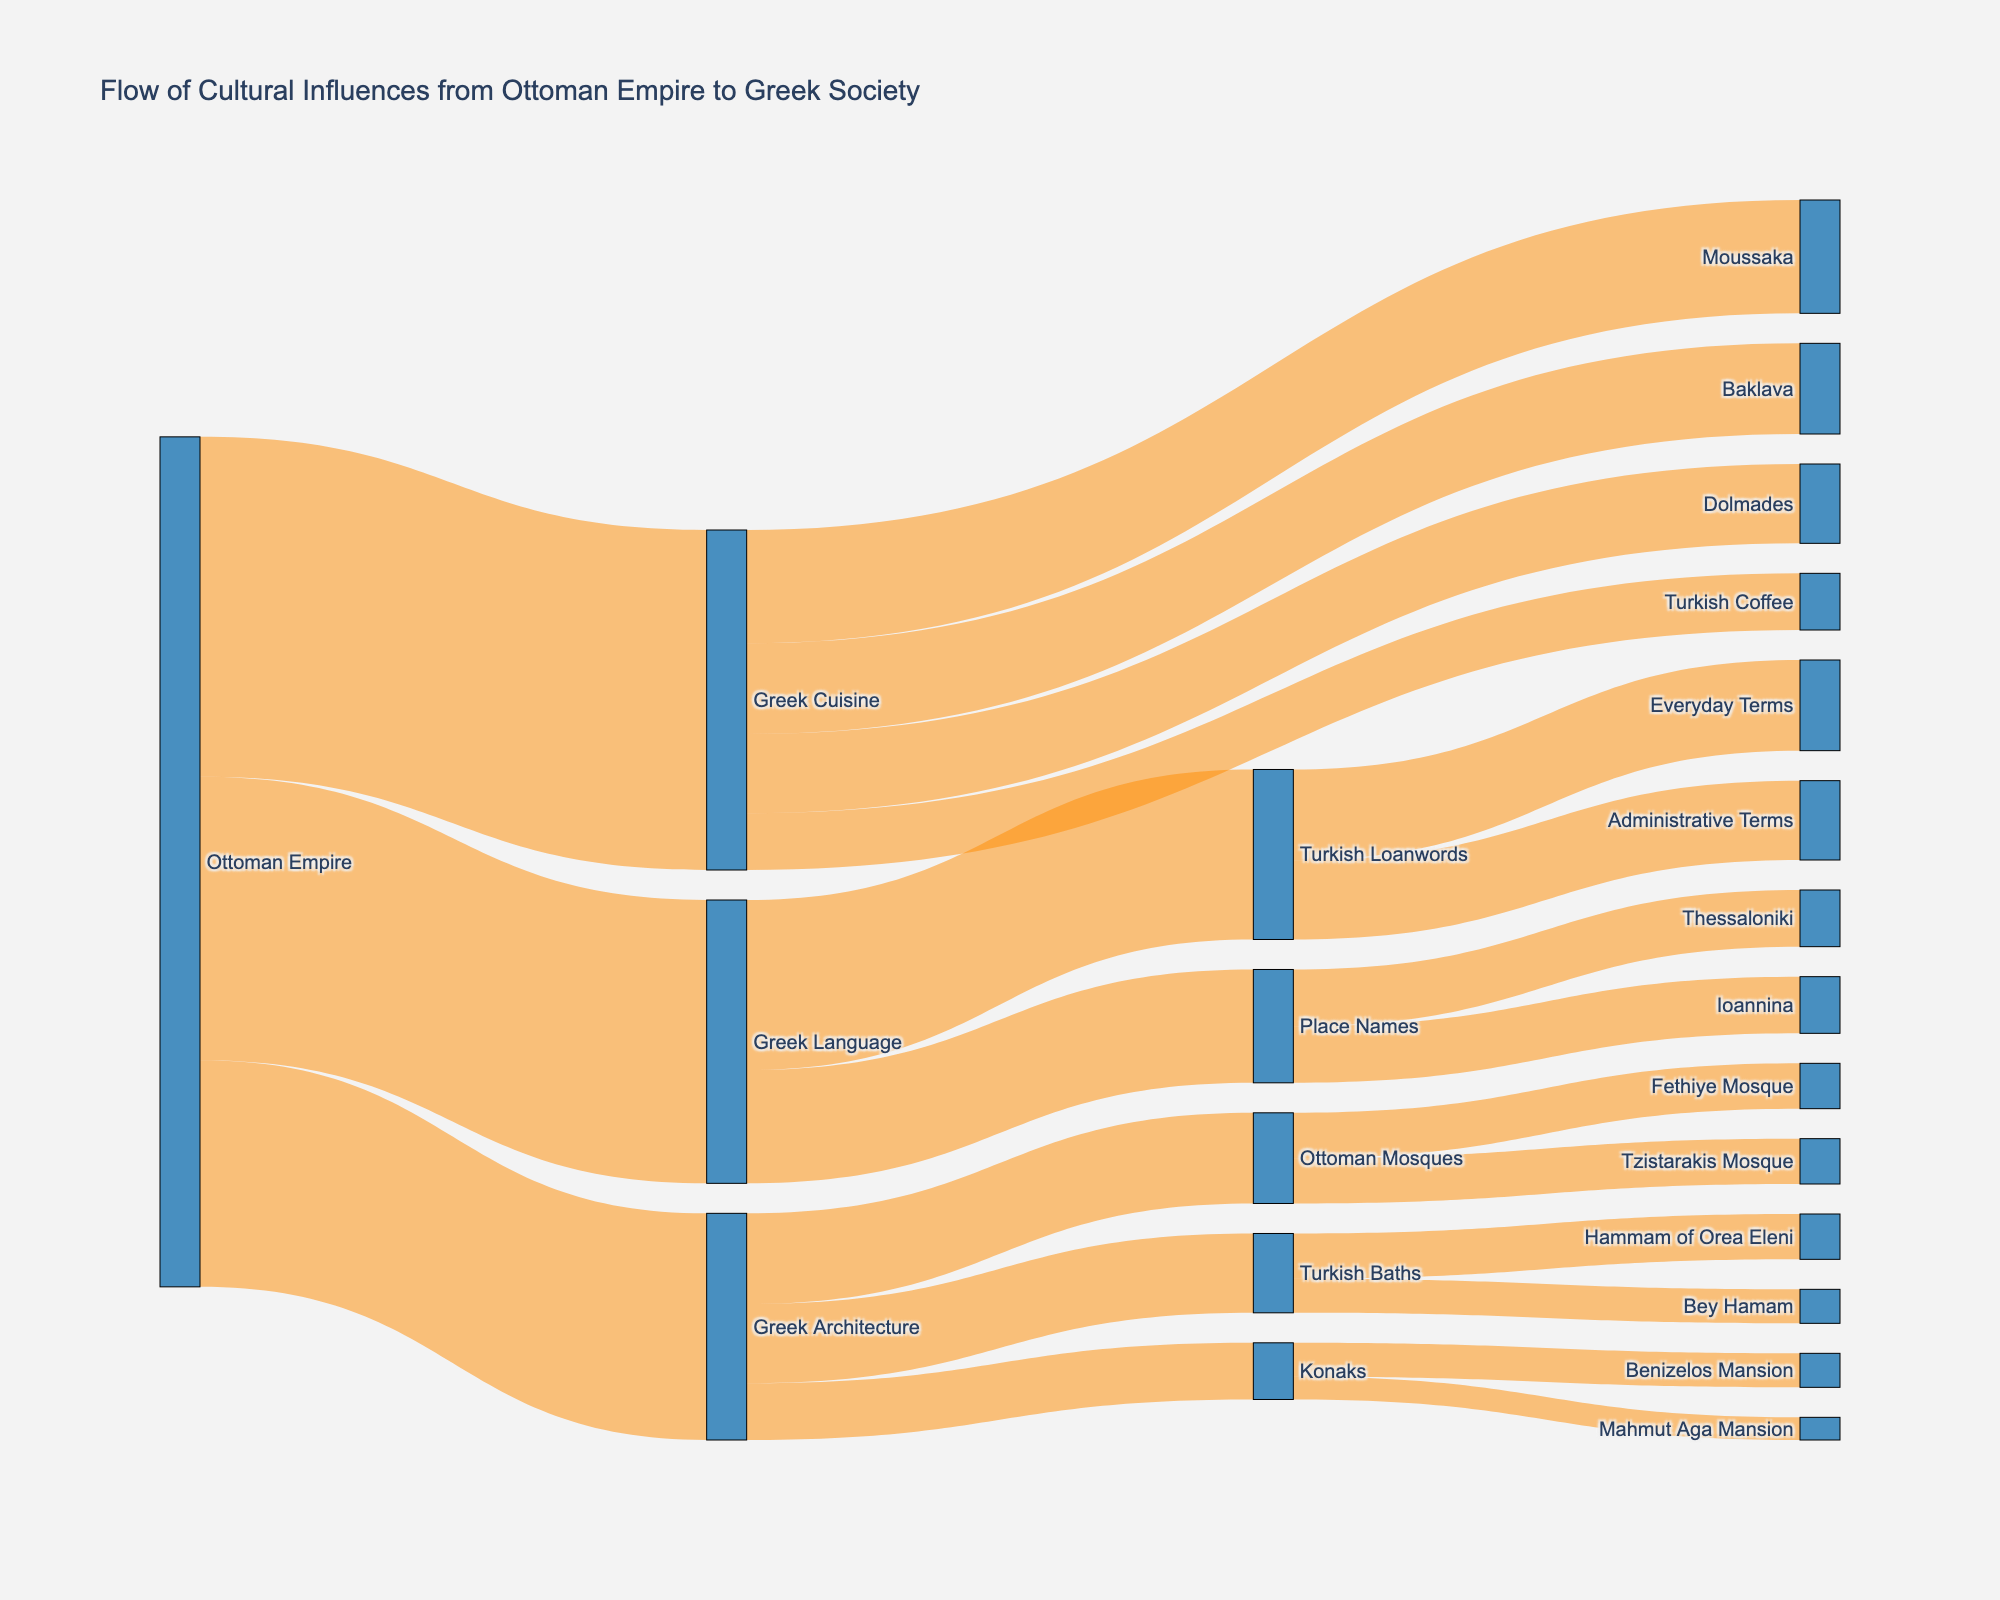What's the title of the Sankey diagram? The title of the Sankey diagram is usually displayed prominently at the top of the plot. In this case, the title is "Flow of Cultural Influences from Ottoman Empire to Greek Society" as defined in the code's layout section.
Answer: Flow of Cultural Influences from Ottoman Empire to Greek Society What is the main source of cultural influences in the diagram? The main source of cultural influences is the node that has outgoing connections to multiple target nodes. In this diagram, the Ottoman Empire is the main source of cultural influences.
Answer: Ottoman Empire Which specific Greek cuisine has the highest influence from the Ottoman Empire, and what is its value? By following the connections from "Ottoman Empire" to "Greek Cuisine" and then to specific dishes, "Moussaka" has the highest influence with a value of 10.
Answer: Moussaka, 10 What is the sum of the values for all influences on Greek Language? The influence values for Greek Language consist of "Turkish Loanwords" (15) and "Place Names" (10). The sum is 15 + 10.
Answer: 25 Compare the influence values of "Greek Architecture" and "Greek Language". Which one is higher and by how much? The influence values are 20 for Greek Architecture and 25 for Greek Language. To find the difference, subtract 20 from 25.
Answer: Greek Language by 5 How many different Greek architectural elements are influenced by the Ottoman Empire, and what are they? There are three different Greek architectural elements influenced by the Ottoman Empire: "Ottoman Mosques", "Turkish Baths", and "Konaks".
Answer: 3, "Ottoman Mosques", "Turkish Baths", "Konaks" Which loanword category contains the most terms, and what is the value? By following the path from "Turkish Loanwords" to its categories, "Everyday Terms" has the most terms with a value of 8.
Answer: Everyday Terms, 8 What is the combined value of the influences from the Ottoman Empire on Greek Cuisine and Greek Architecture? The value for Greek Cuisine is 30, and for Greek Architecture, it is 20. The combined value is 30 + 20.
Answer: 50 Identify the Greek city influenced by Ottoman naming with the highest influence value and state the value. Both "Thessaloniki" and "Ioannina" are influenced by Ottoman naming with an equal value of 5.
Answer: Thessaloniki or Ioannina, 5 How much influence does the Ottoman Empire have on specific Greek Cuisine items other than Moussaka? The influences on other Greek Cuisine items are "Baklava" (8), "Dolmades" (7), and "Turkish Coffee" (5). Summing these values gives the total influence.
Answer: 20 